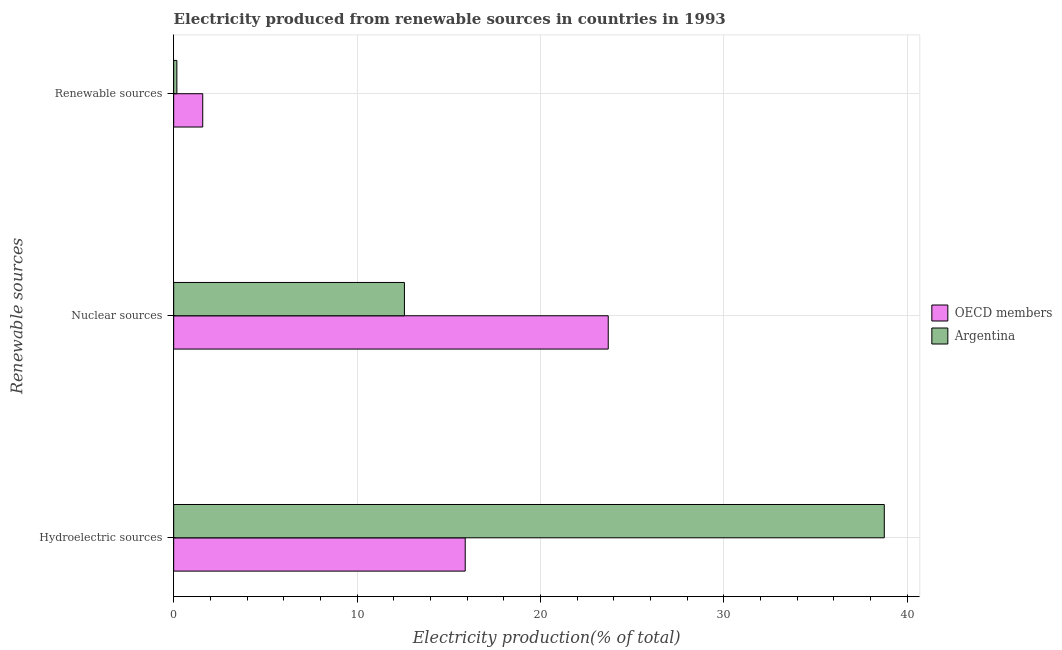Are the number of bars per tick equal to the number of legend labels?
Your response must be concise. Yes. Are the number of bars on each tick of the Y-axis equal?
Your answer should be very brief. Yes. What is the label of the 1st group of bars from the top?
Ensure brevity in your answer.  Renewable sources. What is the percentage of electricity produced by hydroelectric sources in Argentina?
Keep it short and to the point. 38.76. Across all countries, what is the maximum percentage of electricity produced by hydroelectric sources?
Keep it short and to the point. 38.76. Across all countries, what is the minimum percentage of electricity produced by renewable sources?
Your answer should be very brief. 0.17. What is the total percentage of electricity produced by hydroelectric sources in the graph?
Provide a succinct answer. 54.66. What is the difference between the percentage of electricity produced by nuclear sources in Argentina and that in OECD members?
Provide a succinct answer. -11.12. What is the difference between the percentage of electricity produced by hydroelectric sources in Argentina and the percentage of electricity produced by nuclear sources in OECD members?
Your answer should be compact. 15.06. What is the average percentage of electricity produced by nuclear sources per country?
Your response must be concise. 18.14. What is the difference between the percentage of electricity produced by hydroelectric sources and percentage of electricity produced by renewable sources in Argentina?
Provide a succinct answer. 38.59. In how many countries, is the percentage of electricity produced by renewable sources greater than 34 %?
Your answer should be very brief. 0. What is the ratio of the percentage of electricity produced by renewable sources in Argentina to that in OECD members?
Your response must be concise. 0.11. Is the percentage of electricity produced by renewable sources in Argentina less than that in OECD members?
Keep it short and to the point. Yes. Is the difference between the percentage of electricity produced by renewable sources in OECD members and Argentina greater than the difference between the percentage of electricity produced by nuclear sources in OECD members and Argentina?
Provide a succinct answer. No. What is the difference between the highest and the second highest percentage of electricity produced by renewable sources?
Provide a short and direct response. 1.41. What is the difference between the highest and the lowest percentage of electricity produced by nuclear sources?
Keep it short and to the point. 11.12. In how many countries, is the percentage of electricity produced by renewable sources greater than the average percentage of electricity produced by renewable sources taken over all countries?
Provide a succinct answer. 1. What does the 1st bar from the bottom in Renewable sources represents?
Offer a very short reply. OECD members. Is it the case that in every country, the sum of the percentage of electricity produced by hydroelectric sources and percentage of electricity produced by nuclear sources is greater than the percentage of electricity produced by renewable sources?
Ensure brevity in your answer.  Yes. How many bars are there?
Keep it short and to the point. 6. How many countries are there in the graph?
Give a very brief answer. 2. What is the difference between two consecutive major ticks on the X-axis?
Ensure brevity in your answer.  10. Are the values on the major ticks of X-axis written in scientific E-notation?
Offer a terse response. No. Does the graph contain any zero values?
Your response must be concise. No. What is the title of the graph?
Give a very brief answer. Electricity produced from renewable sources in countries in 1993. Does "Bolivia" appear as one of the legend labels in the graph?
Provide a short and direct response. No. What is the label or title of the Y-axis?
Offer a very short reply. Renewable sources. What is the Electricity production(% of total) in OECD members in Hydroelectric sources?
Keep it short and to the point. 15.9. What is the Electricity production(% of total) of Argentina in Hydroelectric sources?
Your answer should be compact. 38.76. What is the Electricity production(% of total) in OECD members in Nuclear sources?
Keep it short and to the point. 23.7. What is the Electricity production(% of total) of Argentina in Nuclear sources?
Give a very brief answer. 12.59. What is the Electricity production(% of total) in OECD members in Renewable sources?
Your answer should be compact. 1.59. What is the Electricity production(% of total) in Argentina in Renewable sources?
Your answer should be very brief. 0.17. Across all Renewable sources, what is the maximum Electricity production(% of total) of OECD members?
Make the answer very short. 23.7. Across all Renewable sources, what is the maximum Electricity production(% of total) of Argentina?
Offer a very short reply. 38.76. Across all Renewable sources, what is the minimum Electricity production(% of total) in OECD members?
Keep it short and to the point. 1.59. Across all Renewable sources, what is the minimum Electricity production(% of total) of Argentina?
Provide a short and direct response. 0.17. What is the total Electricity production(% of total) in OECD members in the graph?
Keep it short and to the point. 41.19. What is the total Electricity production(% of total) of Argentina in the graph?
Your answer should be compact. 51.52. What is the difference between the Electricity production(% of total) in OECD members in Hydroelectric sources and that in Nuclear sources?
Offer a terse response. -7.8. What is the difference between the Electricity production(% of total) in Argentina in Hydroelectric sources and that in Nuclear sources?
Your answer should be very brief. 26.17. What is the difference between the Electricity production(% of total) in OECD members in Hydroelectric sources and that in Renewable sources?
Give a very brief answer. 14.32. What is the difference between the Electricity production(% of total) in Argentina in Hydroelectric sources and that in Renewable sources?
Offer a very short reply. 38.59. What is the difference between the Electricity production(% of total) in OECD members in Nuclear sources and that in Renewable sources?
Your answer should be very brief. 22.12. What is the difference between the Electricity production(% of total) of Argentina in Nuclear sources and that in Renewable sources?
Provide a succinct answer. 12.41. What is the difference between the Electricity production(% of total) of OECD members in Hydroelectric sources and the Electricity production(% of total) of Argentina in Nuclear sources?
Provide a succinct answer. 3.32. What is the difference between the Electricity production(% of total) in OECD members in Hydroelectric sources and the Electricity production(% of total) in Argentina in Renewable sources?
Provide a short and direct response. 15.73. What is the difference between the Electricity production(% of total) of OECD members in Nuclear sources and the Electricity production(% of total) of Argentina in Renewable sources?
Your answer should be very brief. 23.53. What is the average Electricity production(% of total) in OECD members per Renewable sources?
Make the answer very short. 13.73. What is the average Electricity production(% of total) of Argentina per Renewable sources?
Offer a terse response. 17.17. What is the difference between the Electricity production(% of total) of OECD members and Electricity production(% of total) of Argentina in Hydroelectric sources?
Your response must be concise. -22.86. What is the difference between the Electricity production(% of total) in OECD members and Electricity production(% of total) in Argentina in Nuclear sources?
Ensure brevity in your answer.  11.12. What is the difference between the Electricity production(% of total) in OECD members and Electricity production(% of total) in Argentina in Renewable sources?
Offer a terse response. 1.41. What is the ratio of the Electricity production(% of total) in OECD members in Hydroelectric sources to that in Nuclear sources?
Provide a succinct answer. 0.67. What is the ratio of the Electricity production(% of total) of Argentina in Hydroelectric sources to that in Nuclear sources?
Your answer should be compact. 3.08. What is the ratio of the Electricity production(% of total) in OECD members in Hydroelectric sources to that in Renewable sources?
Your response must be concise. 10.03. What is the ratio of the Electricity production(% of total) in Argentina in Hydroelectric sources to that in Renewable sources?
Your answer should be very brief. 223.06. What is the ratio of the Electricity production(% of total) of OECD members in Nuclear sources to that in Renewable sources?
Your answer should be compact. 14.95. What is the ratio of the Electricity production(% of total) in Argentina in Nuclear sources to that in Renewable sources?
Your answer should be compact. 72.43. What is the difference between the highest and the second highest Electricity production(% of total) of OECD members?
Your answer should be compact. 7.8. What is the difference between the highest and the second highest Electricity production(% of total) in Argentina?
Your answer should be compact. 26.17. What is the difference between the highest and the lowest Electricity production(% of total) in OECD members?
Provide a succinct answer. 22.12. What is the difference between the highest and the lowest Electricity production(% of total) in Argentina?
Your answer should be very brief. 38.59. 